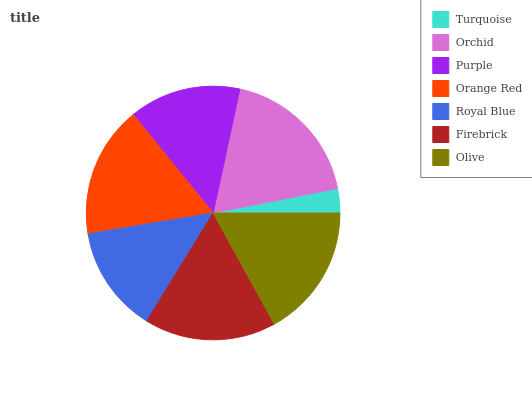Is Turquoise the minimum?
Answer yes or no. Yes. Is Orchid the maximum?
Answer yes or no. Yes. Is Purple the minimum?
Answer yes or no. No. Is Purple the maximum?
Answer yes or no. No. Is Orchid greater than Purple?
Answer yes or no. Yes. Is Purple less than Orchid?
Answer yes or no. Yes. Is Purple greater than Orchid?
Answer yes or no. No. Is Orchid less than Purple?
Answer yes or no. No. Is Orange Red the high median?
Answer yes or no. Yes. Is Orange Red the low median?
Answer yes or no. Yes. Is Olive the high median?
Answer yes or no. No. Is Olive the low median?
Answer yes or no. No. 